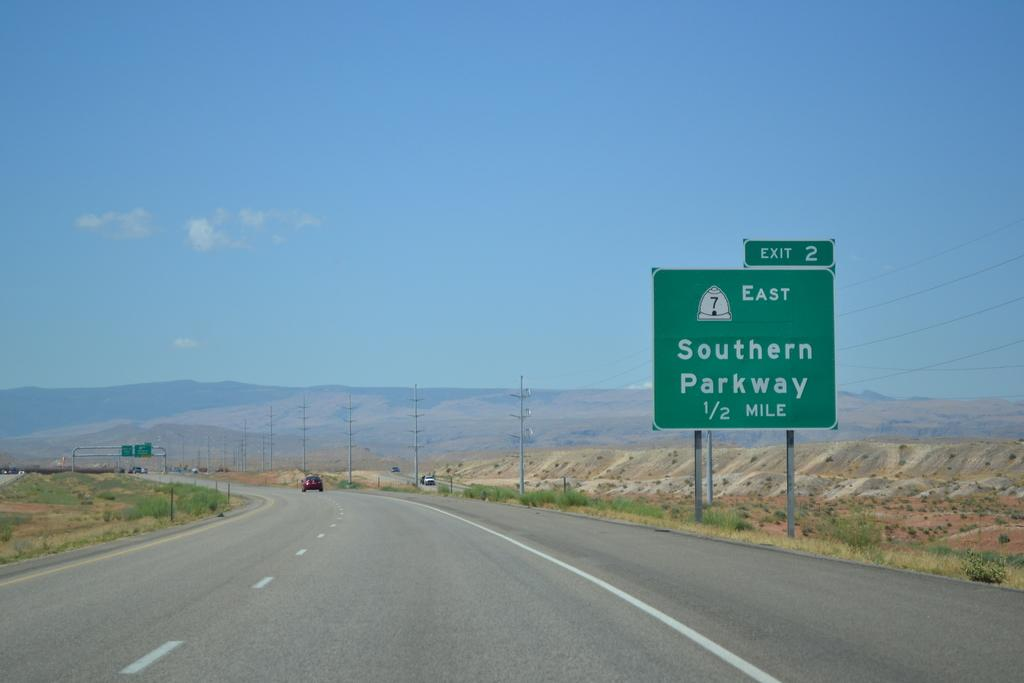<image>
Present a compact description of the photo's key features. A long road that is next to a green sign reading that the next Exit is in 1/2 mile. 